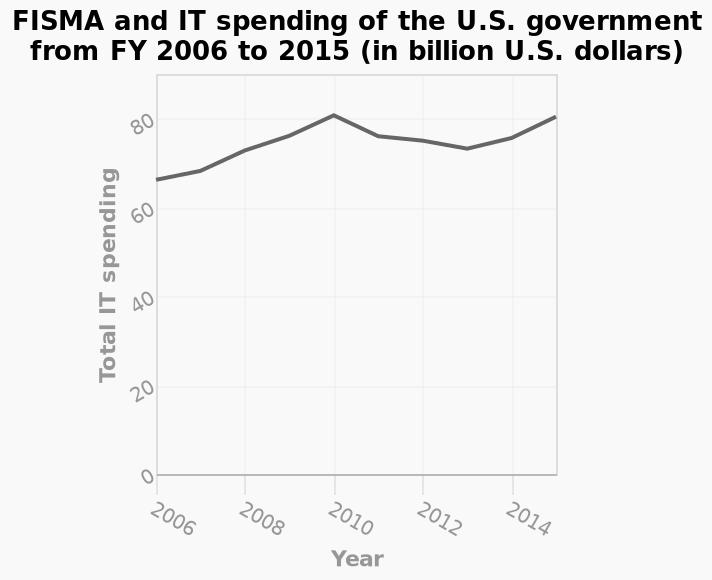<image>
Did spending return to the peak level after 2010? Yes, spending returned to the peak level in 2014. 